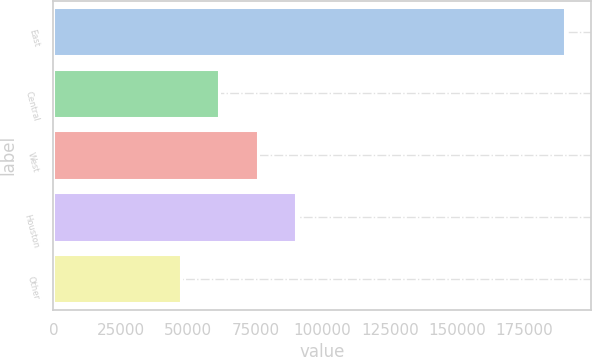Convert chart. <chart><loc_0><loc_0><loc_500><loc_500><bar_chart><fcel>East<fcel>Central<fcel>West<fcel>Houston<fcel>Other<nl><fcel>190095<fcel>61651.5<fcel>75923<fcel>90194.5<fcel>47380<nl></chart> 